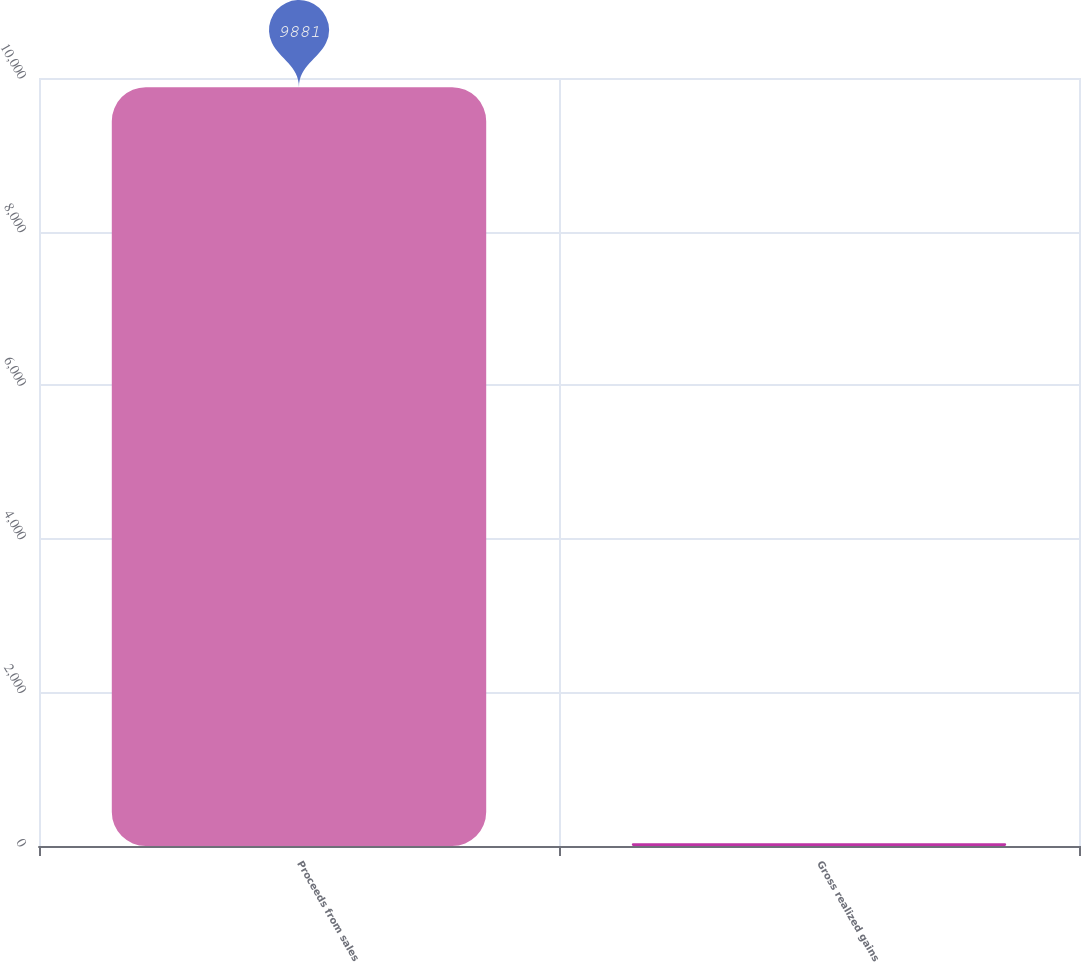Convert chart to OTSL. <chart><loc_0><loc_0><loc_500><loc_500><bar_chart><fcel>Proceeds from sales<fcel>Gross realized gains<nl><fcel>9881<fcel>36<nl></chart> 